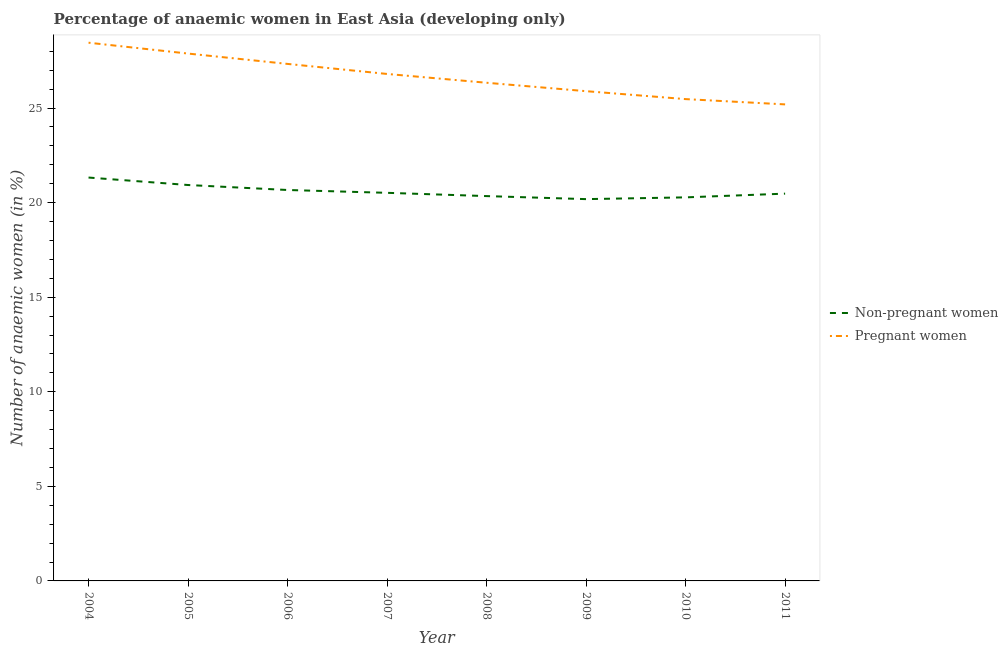How many different coloured lines are there?
Provide a short and direct response. 2. What is the percentage of pregnant anaemic women in 2004?
Offer a very short reply. 28.46. Across all years, what is the maximum percentage of non-pregnant anaemic women?
Your response must be concise. 21.33. Across all years, what is the minimum percentage of non-pregnant anaemic women?
Give a very brief answer. 20.19. In which year was the percentage of non-pregnant anaemic women minimum?
Make the answer very short. 2009. What is the total percentage of pregnant anaemic women in the graph?
Keep it short and to the point. 213.38. What is the difference between the percentage of non-pregnant anaemic women in 2005 and that in 2006?
Your answer should be compact. 0.26. What is the difference between the percentage of pregnant anaemic women in 2011 and the percentage of non-pregnant anaemic women in 2008?
Provide a short and direct response. 4.85. What is the average percentage of pregnant anaemic women per year?
Provide a succinct answer. 26.67. In the year 2007, what is the difference between the percentage of non-pregnant anaemic women and percentage of pregnant anaemic women?
Offer a terse response. -6.28. What is the ratio of the percentage of pregnant anaemic women in 2006 to that in 2008?
Provide a short and direct response. 1.04. Is the difference between the percentage of non-pregnant anaemic women in 2005 and 2011 greater than the difference between the percentage of pregnant anaemic women in 2005 and 2011?
Give a very brief answer. No. What is the difference between the highest and the second highest percentage of pregnant anaemic women?
Provide a succinct answer. 0.57. What is the difference between the highest and the lowest percentage of pregnant anaemic women?
Your answer should be compact. 3.26. In how many years, is the percentage of non-pregnant anaemic women greater than the average percentage of non-pregnant anaemic women taken over all years?
Provide a succinct answer. 3. Is the sum of the percentage of pregnant anaemic women in 2008 and 2009 greater than the maximum percentage of non-pregnant anaemic women across all years?
Your answer should be compact. Yes. Does the percentage of pregnant anaemic women monotonically increase over the years?
Offer a terse response. No. Is the percentage of pregnant anaemic women strictly greater than the percentage of non-pregnant anaemic women over the years?
Keep it short and to the point. Yes. Is the percentage of non-pregnant anaemic women strictly less than the percentage of pregnant anaemic women over the years?
Offer a very short reply. Yes. How many lines are there?
Provide a succinct answer. 2. How many years are there in the graph?
Keep it short and to the point. 8. Does the graph contain any zero values?
Provide a succinct answer. No. Does the graph contain grids?
Your response must be concise. No. Where does the legend appear in the graph?
Your answer should be very brief. Center right. What is the title of the graph?
Provide a short and direct response. Percentage of anaemic women in East Asia (developing only). Does "Fixed telephone" appear as one of the legend labels in the graph?
Ensure brevity in your answer.  No. What is the label or title of the Y-axis?
Offer a terse response. Number of anaemic women (in %). What is the Number of anaemic women (in %) of Non-pregnant women in 2004?
Offer a very short reply. 21.33. What is the Number of anaemic women (in %) of Pregnant women in 2004?
Keep it short and to the point. 28.46. What is the Number of anaemic women (in %) in Non-pregnant women in 2005?
Your answer should be very brief. 20.93. What is the Number of anaemic women (in %) in Pregnant women in 2005?
Your answer should be very brief. 27.88. What is the Number of anaemic women (in %) in Non-pregnant women in 2006?
Keep it short and to the point. 20.67. What is the Number of anaemic women (in %) in Pregnant women in 2006?
Your answer should be very brief. 27.34. What is the Number of anaemic women (in %) in Non-pregnant women in 2007?
Make the answer very short. 20.52. What is the Number of anaemic women (in %) in Pregnant women in 2007?
Your response must be concise. 26.8. What is the Number of anaemic women (in %) of Non-pregnant women in 2008?
Provide a succinct answer. 20.35. What is the Number of anaemic women (in %) of Pregnant women in 2008?
Offer a very short reply. 26.34. What is the Number of anaemic women (in %) of Non-pregnant women in 2009?
Give a very brief answer. 20.19. What is the Number of anaemic women (in %) of Pregnant women in 2009?
Offer a terse response. 25.89. What is the Number of anaemic women (in %) in Non-pregnant women in 2010?
Make the answer very short. 20.28. What is the Number of anaemic women (in %) in Pregnant women in 2010?
Give a very brief answer. 25.47. What is the Number of anaemic women (in %) in Non-pregnant women in 2011?
Give a very brief answer. 20.48. What is the Number of anaemic women (in %) in Pregnant women in 2011?
Provide a succinct answer. 25.2. Across all years, what is the maximum Number of anaemic women (in %) in Non-pregnant women?
Your answer should be compact. 21.33. Across all years, what is the maximum Number of anaemic women (in %) of Pregnant women?
Your response must be concise. 28.46. Across all years, what is the minimum Number of anaemic women (in %) of Non-pregnant women?
Your answer should be very brief. 20.19. Across all years, what is the minimum Number of anaemic women (in %) of Pregnant women?
Your answer should be compact. 25.2. What is the total Number of anaemic women (in %) in Non-pregnant women in the graph?
Provide a succinct answer. 164.74. What is the total Number of anaemic women (in %) of Pregnant women in the graph?
Provide a succinct answer. 213.38. What is the difference between the Number of anaemic women (in %) of Non-pregnant women in 2004 and that in 2005?
Provide a succinct answer. 0.39. What is the difference between the Number of anaemic women (in %) in Pregnant women in 2004 and that in 2005?
Your answer should be very brief. 0.57. What is the difference between the Number of anaemic women (in %) in Non-pregnant women in 2004 and that in 2006?
Ensure brevity in your answer.  0.66. What is the difference between the Number of anaemic women (in %) of Pregnant women in 2004 and that in 2006?
Your answer should be compact. 1.12. What is the difference between the Number of anaemic women (in %) of Non-pregnant women in 2004 and that in 2007?
Ensure brevity in your answer.  0.81. What is the difference between the Number of anaemic women (in %) in Pregnant women in 2004 and that in 2007?
Your answer should be very brief. 1.65. What is the difference between the Number of anaemic women (in %) in Non-pregnant women in 2004 and that in 2008?
Offer a very short reply. 0.98. What is the difference between the Number of anaemic women (in %) in Pregnant women in 2004 and that in 2008?
Make the answer very short. 2.12. What is the difference between the Number of anaemic women (in %) of Non-pregnant women in 2004 and that in 2009?
Provide a short and direct response. 1.14. What is the difference between the Number of anaemic women (in %) in Pregnant women in 2004 and that in 2009?
Your answer should be very brief. 2.56. What is the difference between the Number of anaemic women (in %) of Non-pregnant women in 2004 and that in 2010?
Keep it short and to the point. 1.05. What is the difference between the Number of anaemic women (in %) in Pregnant women in 2004 and that in 2010?
Your answer should be very brief. 2.98. What is the difference between the Number of anaemic women (in %) of Non-pregnant women in 2004 and that in 2011?
Your response must be concise. 0.85. What is the difference between the Number of anaemic women (in %) in Pregnant women in 2004 and that in 2011?
Your answer should be very brief. 3.26. What is the difference between the Number of anaemic women (in %) in Non-pregnant women in 2005 and that in 2006?
Provide a succinct answer. 0.26. What is the difference between the Number of anaemic women (in %) of Pregnant women in 2005 and that in 2006?
Give a very brief answer. 0.55. What is the difference between the Number of anaemic women (in %) in Non-pregnant women in 2005 and that in 2007?
Ensure brevity in your answer.  0.41. What is the difference between the Number of anaemic women (in %) in Pregnant women in 2005 and that in 2007?
Your answer should be compact. 1.08. What is the difference between the Number of anaemic women (in %) of Non-pregnant women in 2005 and that in 2008?
Ensure brevity in your answer.  0.59. What is the difference between the Number of anaemic women (in %) of Pregnant women in 2005 and that in 2008?
Your answer should be compact. 1.54. What is the difference between the Number of anaemic women (in %) in Non-pregnant women in 2005 and that in 2009?
Give a very brief answer. 0.75. What is the difference between the Number of anaemic women (in %) of Pregnant women in 2005 and that in 2009?
Make the answer very short. 1.99. What is the difference between the Number of anaemic women (in %) in Non-pregnant women in 2005 and that in 2010?
Provide a succinct answer. 0.65. What is the difference between the Number of anaemic women (in %) in Pregnant women in 2005 and that in 2010?
Offer a very short reply. 2.41. What is the difference between the Number of anaemic women (in %) of Non-pregnant women in 2005 and that in 2011?
Make the answer very short. 0.46. What is the difference between the Number of anaemic women (in %) of Pregnant women in 2005 and that in 2011?
Keep it short and to the point. 2.69. What is the difference between the Number of anaemic women (in %) of Non-pregnant women in 2006 and that in 2007?
Keep it short and to the point. 0.15. What is the difference between the Number of anaemic women (in %) in Pregnant women in 2006 and that in 2007?
Provide a short and direct response. 0.53. What is the difference between the Number of anaemic women (in %) in Non-pregnant women in 2006 and that in 2008?
Ensure brevity in your answer.  0.32. What is the difference between the Number of anaemic women (in %) in Non-pregnant women in 2006 and that in 2009?
Ensure brevity in your answer.  0.48. What is the difference between the Number of anaemic women (in %) in Pregnant women in 2006 and that in 2009?
Your answer should be compact. 1.44. What is the difference between the Number of anaemic women (in %) in Non-pregnant women in 2006 and that in 2010?
Provide a short and direct response. 0.39. What is the difference between the Number of anaemic women (in %) in Pregnant women in 2006 and that in 2010?
Provide a short and direct response. 1.86. What is the difference between the Number of anaemic women (in %) of Non-pregnant women in 2006 and that in 2011?
Your answer should be very brief. 0.19. What is the difference between the Number of anaemic women (in %) in Pregnant women in 2006 and that in 2011?
Offer a very short reply. 2.14. What is the difference between the Number of anaemic women (in %) of Non-pregnant women in 2007 and that in 2008?
Make the answer very short. 0.17. What is the difference between the Number of anaemic women (in %) of Pregnant women in 2007 and that in 2008?
Your answer should be compact. 0.47. What is the difference between the Number of anaemic women (in %) of Non-pregnant women in 2007 and that in 2009?
Give a very brief answer. 0.33. What is the difference between the Number of anaemic women (in %) of Pregnant women in 2007 and that in 2009?
Offer a very short reply. 0.91. What is the difference between the Number of anaemic women (in %) in Non-pregnant women in 2007 and that in 2010?
Give a very brief answer. 0.24. What is the difference between the Number of anaemic women (in %) of Pregnant women in 2007 and that in 2010?
Offer a terse response. 1.33. What is the difference between the Number of anaemic women (in %) in Non-pregnant women in 2007 and that in 2011?
Your answer should be very brief. 0.04. What is the difference between the Number of anaemic women (in %) in Pregnant women in 2007 and that in 2011?
Your response must be concise. 1.61. What is the difference between the Number of anaemic women (in %) in Non-pregnant women in 2008 and that in 2009?
Provide a short and direct response. 0.16. What is the difference between the Number of anaemic women (in %) in Pregnant women in 2008 and that in 2009?
Your response must be concise. 0.45. What is the difference between the Number of anaemic women (in %) in Non-pregnant women in 2008 and that in 2010?
Give a very brief answer. 0.07. What is the difference between the Number of anaemic women (in %) in Pregnant women in 2008 and that in 2010?
Offer a terse response. 0.86. What is the difference between the Number of anaemic women (in %) in Non-pregnant women in 2008 and that in 2011?
Make the answer very short. -0.13. What is the difference between the Number of anaemic women (in %) in Pregnant women in 2008 and that in 2011?
Offer a very short reply. 1.14. What is the difference between the Number of anaemic women (in %) of Non-pregnant women in 2009 and that in 2010?
Make the answer very short. -0.09. What is the difference between the Number of anaemic women (in %) in Pregnant women in 2009 and that in 2010?
Keep it short and to the point. 0.42. What is the difference between the Number of anaemic women (in %) in Non-pregnant women in 2009 and that in 2011?
Offer a terse response. -0.29. What is the difference between the Number of anaemic women (in %) in Pregnant women in 2009 and that in 2011?
Offer a terse response. 0.7. What is the difference between the Number of anaemic women (in %) in Non-pregnant women in 2010 and that in 2011?
Make the answer very short. -0.2. What is the difference between the Number of anaemic women (in %) of Pregnant women in 2010 and that in 2011?
Keep it short and to the point. 0.28. What is the difference between the Number of anaemic women (in %) in Non-pregnant women in 2004 and the Number of anaemic women (in %) in Pregnant women in 2005?
Make the answer very short. -6.56. What is the difference between the Number of anaemic women (in %) in Non-pregnant women in 2004 and the Number of anaemic women (in %) in Pregnant women in 2006?
Ensure brevity in your answer.  -6.01. What is the difference between the Number of anaemic women (in %) in Non-pregnant women in 2004 and the Number of anaemic women (in %) in Pregnant women in 2007?
Keep it short and to the point. -5.48. What is the difference between the Number of anaemic women (in %) of Non-pregnant women in 2004 and the Number of anaemic women (in %) of Pregnant women in 2008?
Your response must be concise. -5.01. What is the difference between the Number of anaemic women (in %) in Non-pregnant women in 2004 and the Number of anaemic women (in %) in Pregnant women in 2009?
Offer a terse response. -4.57. What is the difference between the Number of anaemic women (in %) in Non-pregnant women in 2004 and the Number of anaemic women (in %) in Pregnant women in 2010?
Offer a terse response. -4.15. What is the difference between the Number of anaemic women (in %) in Non-pregnant women in 2004 and the Number of anaemic women (in %) in Pregnant women in 2011?
Your response must be concise. -3.87. What is the difference between the Number of anaemic women (in %) of Non-pregnant women in 2005 and the Number of anaemic women (in %) of Pregnant women in 2006?
Keep it short and to the point. -6.4. What is the difference between the Number of anaemic women (in %) in Non-pregnant women in 2005 and the Number of anaemic women (in %) in Pregnant women in 2007?
Your answer should be compact. -5.87. What is the difference between the Number of anaemic women (in %) in Non-pregnant women in 2005 and the Number of anaemic women (in %) in Pregnant women in 2008?
Provide a succinct answer. -5.41. What is the difference between the Number of anaemic women (in %) of Non-pregnant women in 2005 and the Number of anaemic women (in %) of Pregnant women in 2009?
Your answer should be very brief. -4.96. What is the difference between the Number of anaemic women (in %) in Non-pregnant women in 2005 and the Number of anaemic women (in %) in Pregnant women in 2010?
Keep it short and to the point. -4.54. What is the difference between the Number of anaemic women (in %) in Non-pregnant women in 2005 and the Number of anaemic women (in %) in Pregnant women in 2011?
Your answer should be compact. -4.26. What is the difference between the Number of anaemic women (in %) of Non-pregnant women in 2006 and the Number of anaemic women (in %) of Pregnant women in 2007?
Provide a succinct answer. -6.14. What is the difference between the Number of anaemic women (in %) of Non-pregnant women in 2006 and the Number of anaemic women (in %) of Pregnant women in 2008?
Provide a succinct answer. -5.67. What is the difference between the Number of anaemic women (in %) of Non-pregnant women in 2006 and the Number of anaemic women (in %) of Pregnant women in 2009?
Offer a terse response. -5.22. What is the difference between the Number of anaemic women (in %) in Non-pregnant women in 2006 and the Number of anaemic women (in %) in Pregnant women in 2010?
Your answer should be very brief. -4.81. What is the difference between the Number of anaemic women (in %) in Non-pregnant women in 2006 and the Number of anaemic women (in %) in Pregnant women in 2011?
Offer a terse response. -4.53. What is the difference between the Number of anaemic women (in %) of Non-pregnant women in 2007 and the Number of anaemic women (in %) of Pregnant women in 2008?
Keep it short and to the point. -5.82. What is the difference between the Number of anaemic women (in %) of Non-pregnant women in 2007 and the Number of anaemic women (in %) of Pregnant women in 2009?
Provide a short and direct response. -5.37. What is the difference between the Number of anaemic women (in %) in Non-pregnant women in 2007 and the Number of anaemic women (in %) in Pregnant women in 2010?
Keep it short and to the point. -4.95. What is the difference between the Number of anaemic women (in %) in Non-pregnant women in 2007 and the Number of anaemic women (in %) in Pregnant women in 2011?
Your answer should be compact. -4.68. What is the difference between the Number of anaemic women (in %) of Non-pregnant women in 2008 and the Number of anaemic women (in %) of Pregnant women in 2009?
Your answer should be compact. -5.55. What is the difference between the Number of anaemic women (in %) of Non-pregnant women in 2008 and the Number of anaemic women (in %) of Pregnant women in 2010?
Your answer should be compact. -5.13. What is the difference between the Number of anaemic women (in %) in Non-pregnant women in 2008 and the Number of anaemic women (in %) in Pregnant women in 2011?
Offer a terse response. -4.85. What is the difference between the Number of anaemic women (in %) of Non-pregnant women in 2009 and the Number of anaemic women (in %) of Pregnant women in 2010?
Provide a succinct answer. -5.29. What is the difference between the Number of anaemic women (in %) of Non-pregnant women in 2009 and the Number of anaemic women (in %) of Pregnant women in 2011?
Your answer should be compact. -5.01. What is the difference between the Number of anaemic women (in %) of Non-pregnant women in 2010 and the Number of anaemic women (in %) of Pregnant women in 2011?
Provide a short and direct response. -4.92. What is the average Number of anaemic women (in %) of Non-pregnant women per year?
Your response must be concise. 20.59. What is the average Number of anaemic women (in %) of Pregnant women per year?
Make the answer very short. 26.67. In the year 2004, what is the difference between the Number of anaemic women (in %) in Non-pregnant women and Number of anaemic women (in %) in Pregnant women?
Give a very brief answer. -7.13. In the year 2005, what is the difference between the Number of anaemic women (in %) in Non-pregnant women and Number of anaemic women (in %) in Pregnant women?
Ensure brevity in your answer.  -6.95. In the year 2006, what is the difference between the Number of anaemic women (in %) in Non-pregnant women and Number of anaemic women (in %) in Pregnant women?
Give a very brief answer. -6.67. In the year 2007, what is the difference between the Number of anaemic women (in %) in Non-pregnant women and Number of anaemic women (in %) in Pregnant women?
Offer a very short reply. -6.28. In the year 2008, what is the difference between the Number of anaemic women (in %) in Non-pregnant women and Number of anaemic women (in %) in Pregnant women?
Your response must be concise. -5.99. In the year 2009, what is the difference between the Number of anaemic women (in %) in Non-pregnant women and Number of anaemic women (in %) in Pregnant women?
Your answer should be compact. -5.71. In the year 2010, what is the difference between the Number of anaemic women (in %) of Non-pregnant women and Number of anaemic women (in %) of Pregnant women?
Keep it short and to the point. -5.2. In the year 2011, what is the difference between the Number of anaemic women (in %) of Non-pregnant women and Number of anaemic women (in %) of Pregnant women?
Offer a terse response. -4.72. What is the ratio of the Number of anaemic women (in %) in Non-pregnant women in 2004 to that in 2005?
Provide a short and direct response. 1.02. What is the ratio of the Number of anaemic women (in %) in Pregnant women in 2004 to that in 2005?
Your answer should be compact. 1.02. What is the ratio of the Number of anaemic women (in %) in Non-pregnant women in 2004 to that in 2006?
Give a very brief answer. 1.03. What is the ratio of the Number of anaemic women (in %) of Pregnant women in 2004 to that in 2006?
Your answer should be compact. 1.04. What is the ratio of the Number of anaemic women (in %) of Non-pregnant women in 2004 to that in 2007?
Give a very brief answer. 1.04. What is the ratio of the Number of anaemic women (in %) in Pregnant women in 2004 to that in 2007?
Give a very brief answer. 1.06. What is the ratio of the Number of anaemic women (in %) in Non-pregnant women in 2004 to that in 2008?
Your answer should be very brief. 1.05. What is the ratio of the Number of anaemic women (in %) in Pregnant women in 2004 to that in 2008?
Provide a succinct answer. 1.08. What is the ratio of the Number of anaemic women (in %) in Non-pregnant women in 2004 to that in 2009?
Ensure brevity in your answer.  1.06. What is the ratio of the Number of anaemic women (in %) of Pregnant women in 2004 to that in 2009?
Your answer should be very brief. 1.1. What is the ratio of the Number of anaemic women (in %) of Non-pregnant women in 2004 to that in 2010?
Your answer should be very brief. 1.05. What is the ratio of the Number of anaemic women (in %) in Pregnant women in 2004 to that in 2010?
Offer a very short reply. 1.12. What is the ratio of the Number of anaemic women (in %) of Non-pregnant women in 2004 to that in 2011?
Your answer should be compact. 1.04. What is the ratio of the Number of anaemic women (in %) in Pregnant women in 2004 to that in 2011?
Give a very brief answer. 1.13. What is the ratio of the Number of anaemic women (in %) in Non-pregnant women in 2005 to that in 2006?
Provide a succinct answer. 1.01. What is the ratio of the Number of anaemic women (in %) of Non-pregnant women in 2005 to that in 2007?
Your answer should be compact. 1.02. What is the ratio of the Number of anaemic women (in %) in Pregnant women in 2005 to that in 2007?
Give a very brief answer. 1.04. What is the ratio of the Number of anaemic women (in %) of Non-pregnant women in 2005 to that in 2008?
Keep it short and to the point. 1.03. What is the ratio of the Number of anaemic women (in %) in Pregnant women in 2005 to that in 2008?
Make the answer very short. 1.06. What is the ratio of the Number of anaemic women (in %) of Pregnant women in 2005 to that in 2009?
Make the answer very short. 1.08. What is the ratio of the Number of anaemic women (in %) of Non-pregnant women in 2005 to that in 2010?
Ensure brevity in your answer.  1.03. What is the ratio of the Number of anaemic women (in %) in Pregnant women in 2005 to that in 2010?
Your response must be concise. 1.09. What is the ratio of the Number of anaemic women (in %) in Non-pregnant women in 2005 to that in 2011?
Provide a short and direct response. 1.02. What is the ratio of the Number of anaemic women (in %) of Pregnant women in 2005 to that in 2011?
Keep it short and to the point. 1.11. What is the ratio of the Number of anaemic women (in %) in Non-pregnant women in 2006 to that in 2007?
Keep it short and to the point. 1.01. What is the ratio of the Number of anaemic women (in %) in Pregnant women in 2006 to that in 2007?
Ensure brevity in your answer.  1.02. What is the ratio of the Number of anaemic women (in %) of Non-pregnant women in 2006 to that in 2008?
Keep it short and to the point. 1.02. What is the ratio of the Number of anaemic women (in %) in Pregnant women in 2006 to that in 2008?
Offer a very short reply. 1.04. What is the ratio of the Number of anaemic women (in %) in Non-pregnant women in 2006 to that in 2009?
Keep it short and to the point. 1.02. What is the ratio of the Number of anaemic women (in %) in Pregnant women in 2006 to that in 2009?
Offer a very short reply. 1.06. What is the ratio of the Number of anaemic women (in %) in Non-pregnant women in 2006 to that in 2010?
Keep it short and to the point. 1.02. What is the ratio of the Number of anaemic women (in %) in Pregnant women in 2006 to that in 2010?
Keep it short and to the point. 1.07. What is the ratio of the Number of anaemic women (in %) in Non-pregnant women in 2006 to that in 2011?
Your answer should be compact. 1.01. What is the ratio of the Number of anaemic women (in %) in Pregnant women in 2006 to that in 2011?
Your answer should be compact. 1.08. What is the ratio of the Number of anaemic women (in %) in Non-pregnant women in 2007 to that in 2008?
Offer a very short reply. 1.01. What is the ratio of the Number of anaemic women (in %) in Pregnant women in 2007 to that in 2008?
Ensure brevity in your answer.  1.02. What is the ratio of the Number of anaemic women (in %) in Non-pregnant women in 2007 to that in 2009?
Your response must be concise. 1.02. What is the ratio of the Number of anaemic women (in %) of Pregnant women in 2007 to that in 2009?
Your response must be concise. 1.04. What is the ratio of the Number of anaemic women (in %) of Non-pregnant women in 2007 to that in 2010?
Keep it short and to the point. 1.01. What is the ratio of the Number of anaemic women (in %) of Pregnant women in 2007 to that in 2010?
Keep it short and to the point. 1.05. What is the ratio of the Number of anaemic women (in %) in Pregnant women in 2007 to that in 2011?
Give a very brief answer. 1.06. What is the ratio of the Number of anaemic women (in %) in Non-pregnant women in 2008 to that in 2009?
Provide a succinct answer. 1.01. What is the ratio of the Number of anaemic women (in %) in Pregnant women in 2008 to that in 2009?
Your response must be concise. 1.02. What is the ratio of the Number of anaemic women (in %) in Non-pregnant women in 2008 to that in 2010?
Offer a terse response. 1. What is the ratio of the Number of anaemic women (in %) in Pregnant women in 2008 to that in 2010?
Provide a succinct answer. 1.03. What is the ratio of the Number of anaemic women (in %) of Non-pregnant women in 2008 to that in 2011?
Provide a short and direct response. 0.99. What is the ratio of the Number of anaemic women (in %) of Pregnant women in 2008 to that in 2011?
Offer a terse response. 1.05. What is the ratio of the Number of anaemic women (in %) in Non-pregnant women in 2009 to that in 2010?
Provide a succinct answer. 1. What is the ratio of the Number of anaemic women (in %) in Pregnant women in 2009 to that in 2010?
Your answer should be compact. 1.02. What is the ratio of the Number of anaemic women (in %) of Non-pregnant women in 2009 to that in 2011?
Keep it short and to the point. 0.99. What is the ratio of the Number of anaemic women (in %) in Pregnant women in 2009 to that in 2011?
Give a very brief answer. 1.03. What is the ratio of the Number of anaemic women (in %) of Non-pregnant women in 2010 to that in 2011?
Make the answer very short. 0.99. What is the ratio of the Number of anaemic women (in %) of Pregnant women in 2010 to that in 2011?
Your answer should be compact. 1.01. What is the difference between the highest and the second highest Number of anaemic women (in %) of Non-pregnant women?
Offer a very short reply. 0.39. What is the difference between the highest and the second highest Number of anaemic women (in %) in Pregnant women?
Give a very brief answer. 0.57. What is the difference between the highest and the lowest Number of anaemic women (in %) in Non-pregnant women?
Provide a succinct answer. 1.14. What is the difference between the highest and the lowest Number of anaemic women (in %) of Pregnant women?
Provide a succinct answer. 3.26. 